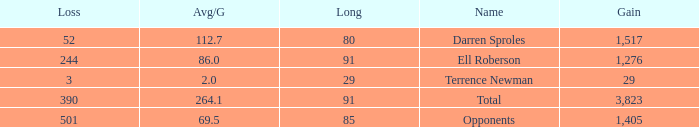When the player gained below 1,405 yards and lost over 390 yards, what's the sum of the long yards? None. 